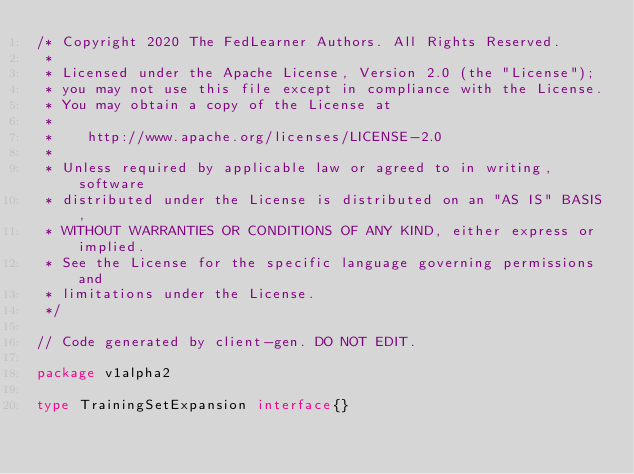<code> <loc_0><loc_0><loc_500><loc_500><_Go_>/* Copyright 2020 The FedLearner Authors. All Rights Reserved.
 *
 * Licensed under the Apache License, Version 2.0 (the "License");
 * you may not use this file except in compliance with the License.
 * You may obtain a copy of the License at
 *
 *    http://www.apache.org/licenses/LICENSE-2.0
 *
 * Unless required by applicable law or agreed to in writing, software
 * distributed under the License is distributed on an "AS IS" BASIS,
 * WITHOUT WARRANTIES OR CONDITIONS OF ANY KIND, either express or implied.
 * See the License for the specific language governing permissions and
 * limitations under the License.
 */

// Code generated by client-gen. DO NOT EDIT.

package v1alpha2

type TrainingSetExpansion interface{}
</code> 